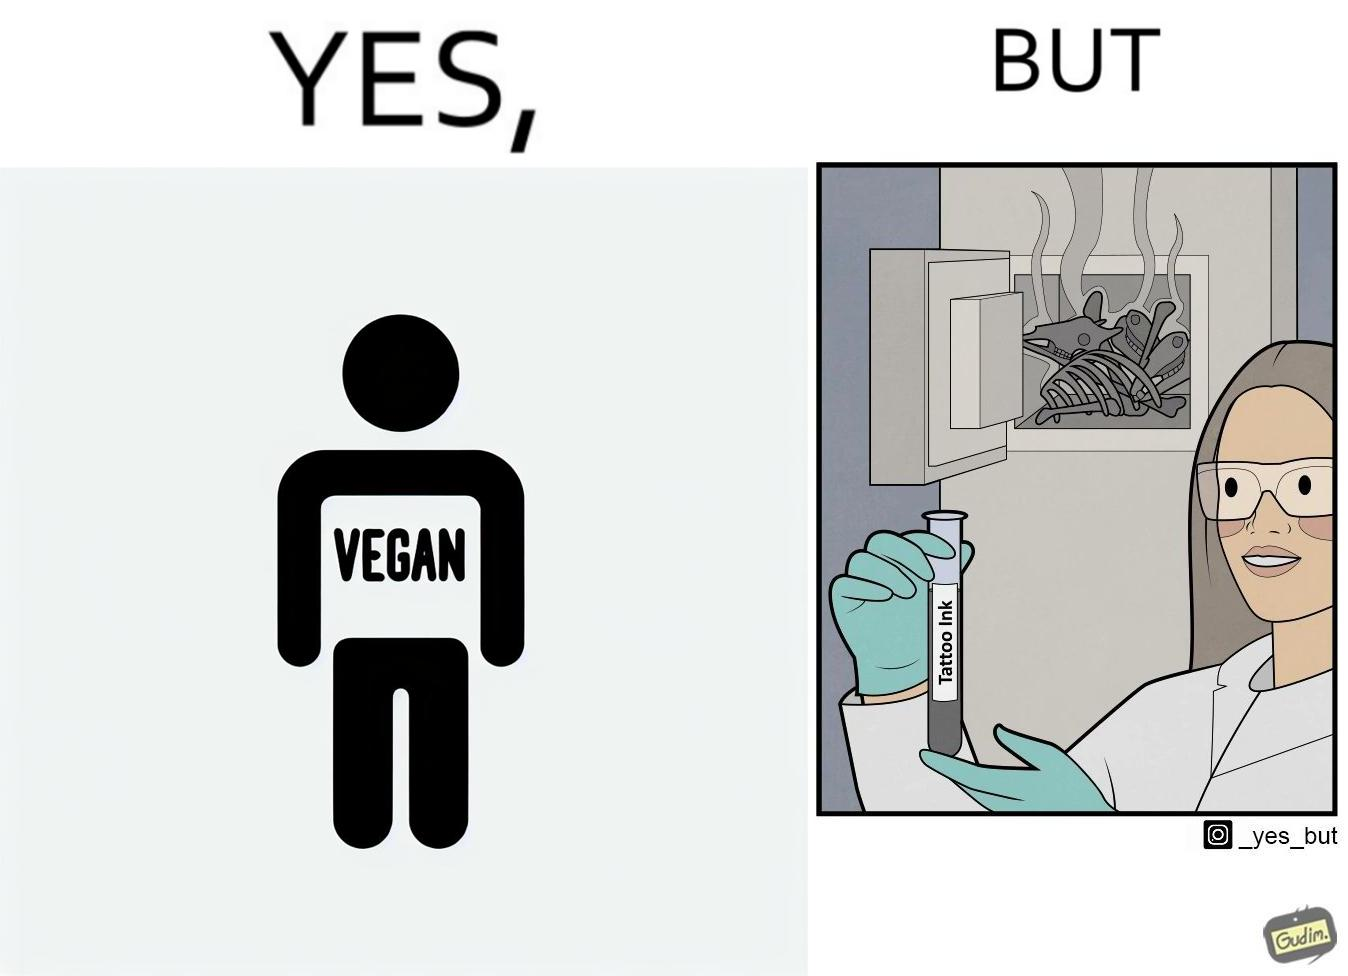What is shown in this image? The irony in this video is that people try to promote and embrace veganism end up using products that are not animal-free. 